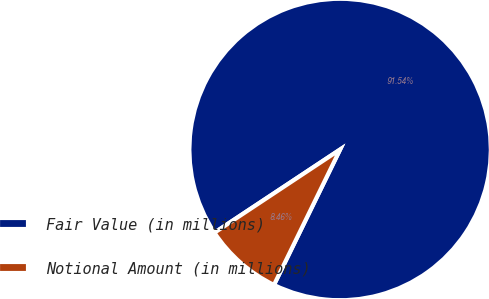Convert chart to OTSL. <chart><loc_0><loc_0><loc_500><loc_500><pie_chart><fcel>Fair Value (in millions)<fcel>Notional Amount (in millions)<nl><fcel>91.54%<fcel>8.46%<nl></chart> 